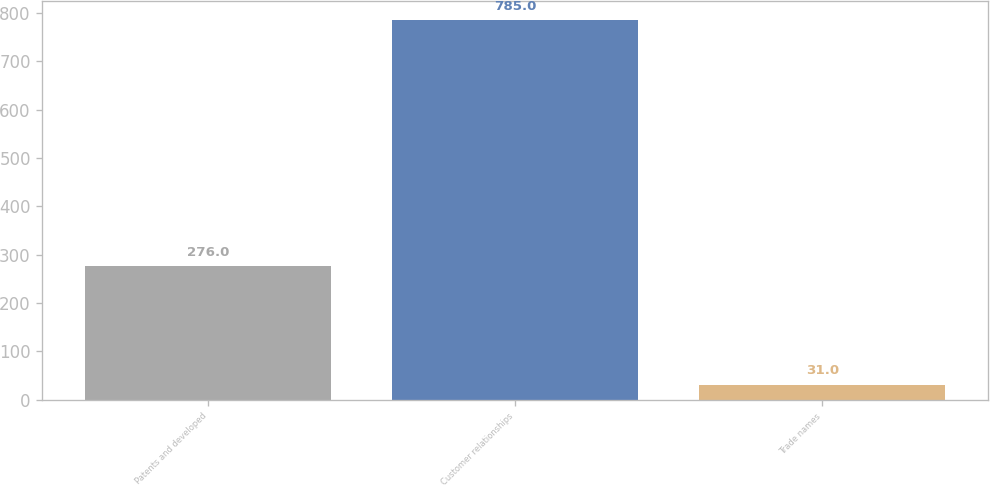Convert chart. <chart><loc_0><loc_0><loc_500><loc_500><bar_chart><fcel>Patents and developed<fcel>Customer relationships<fcel>Trade names<nl><fcel>276<fcel>785<fcel>31<nl></chart> 